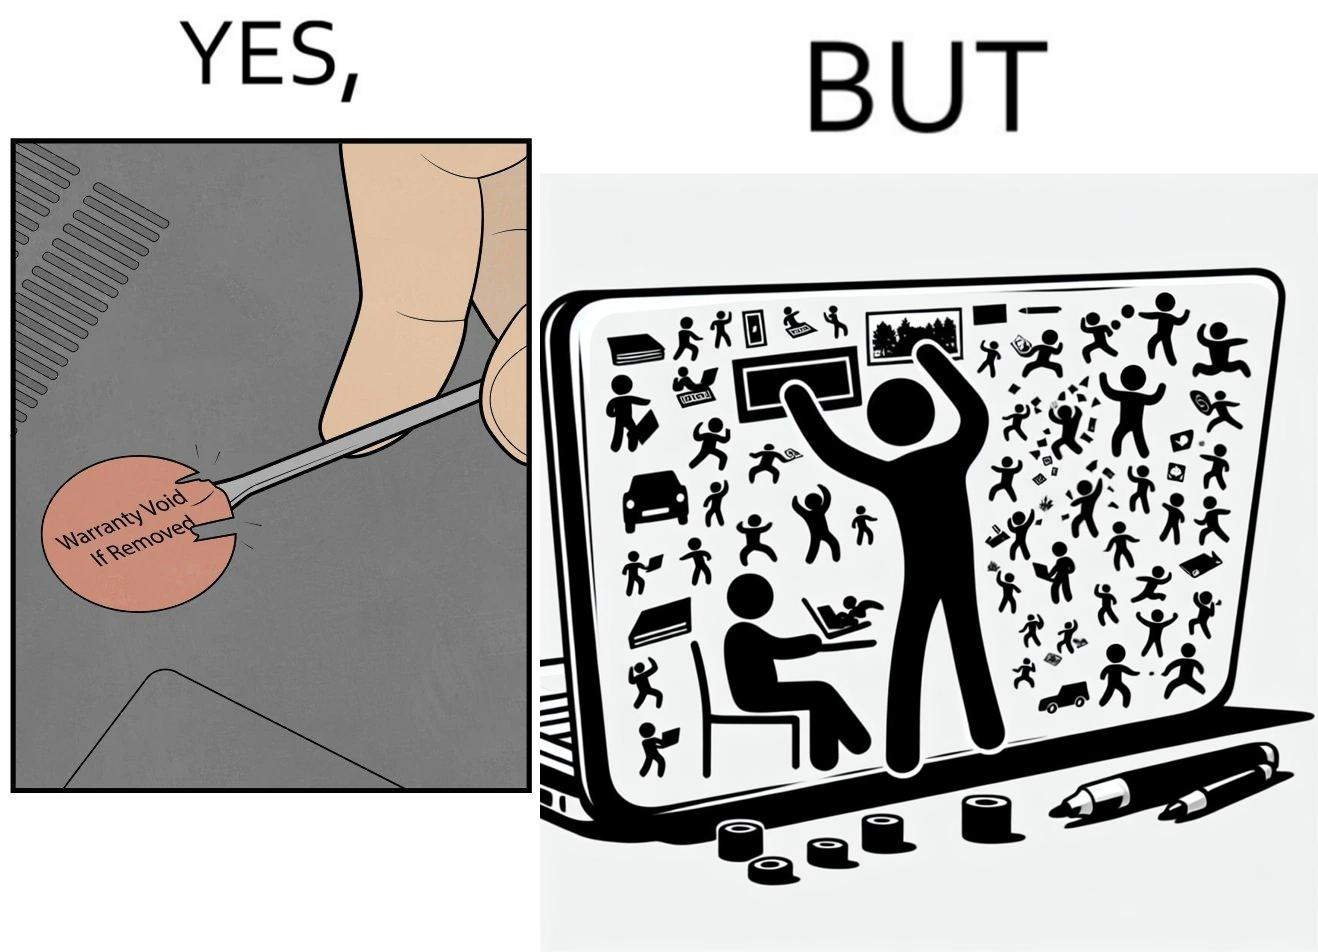Describe the satirical element in this image. The images are funny since it shows how an user chooses to remove a rather important warranty sticker because it does not look good, but chooses to fill his laptop with useless stickers just to decorate the laptop 